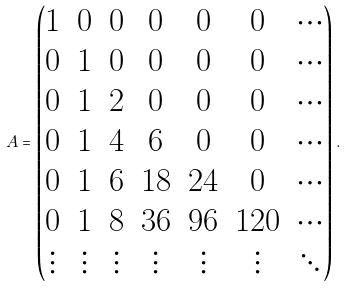Convert formula to latex. <formula><loc_0><loc_0><loc_500><loc_500>A = \begin{pmatrix} 1 & 0 & 0 & 0 & 0 & 0 & \cdots \\ 0 & 1 & 0 & 0 & 0 & 0 & \cdots \\ 0 & 1 & 2 & 0 & 0 & 0 & \cdots \\ 0 & 1 & 4 & 6 & 0 & 0 & \cdots \\ 0 & 1 & 6 & 1 8 & 2 4 & 0 & \cdots \\ 0 & 1 & 8 & 3 6 & 9 6 & 1 2 0 & \cdots \\ \vdots & \vdots & \vdots & \vdots & \vdots & \vdots & \ddots \end{pmatrix} .</formula> 